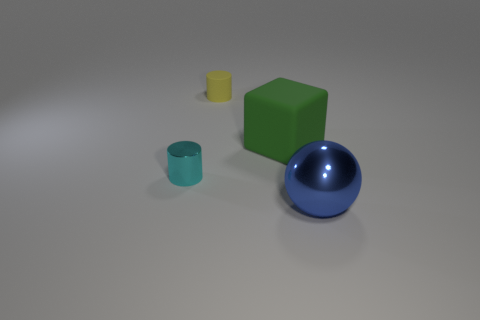How many brown balls are the same size as the blue sphere?
Provide a succinct answer. 0. What number of objects are either rubber objects to the left of the rubber cube or cylinders that are to the right of the small metallic object?
Provide a succinct answer. 1. Is the cylinder that is in front of the small matte cylinder made of the same material as the thing on the right side of the green matte block?
Offer a terse response. Yes. What shape is the object left of the rubber cylinder that is on the left side of the large rubber block?
Provide a succinct answer. Cylinder. Is there any other thing that is the same color as the big metallic object?
Provide a succinct answer. No. There is a small cylinder behind the cylinder that is in front of the matte block; is there a big blue object that is in front of it?
Keep it short and to the point. Yes. There is a big thing that is behind the big metallic sphere; does it have the same color as the big thing in front of the big rubber thing?
Make the answer very short. No. There is a cylinder that is the same size as the yellow object; what material is it?
Give a very brief answer. Metal. What size is the metal thing that is behind the blue sphere that is in front of the big thing behind the large ball?
Your response must be concise. Small. What size is the cylinder that is in front of the large green matte cube?
Your answer should be very brief. Small. 